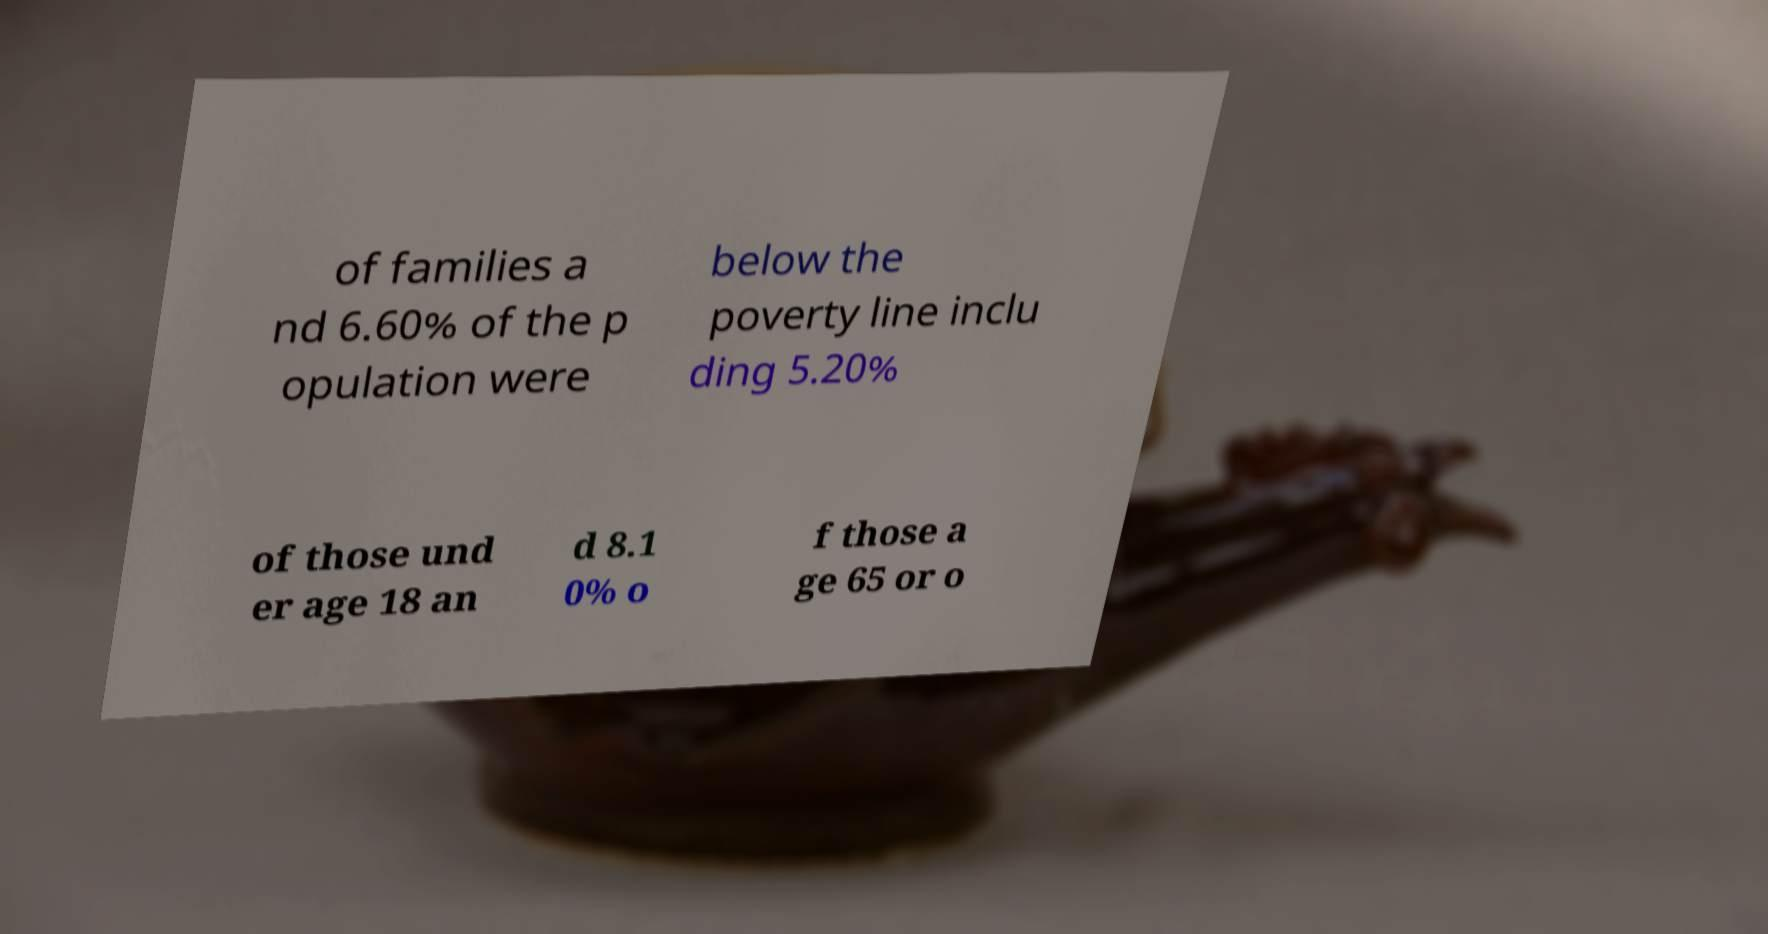What messages or text are displayed in this image? I need them in a readable, typed format. of families a nd 6.60% of the p opulation were below the poverty line inclu ding 5.20% of those und er age 18 an d 8.1 0% o f those a ge 65 or o 